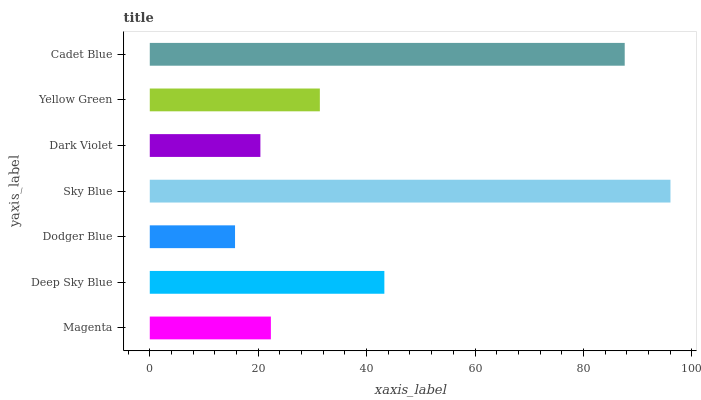Is Dodger Blue the minimum?
Answer yes or no. Yes. Is Sky Blue the maximum?
Answer yes or no. Yes. Is Deep Sky Blue the minimum?
Answer yes or no. No. Is Deep Sky Blue the maximum?
Answer yes or no. No. Is Deep Sky Blue greater than Magenta?
Answer yes or no. Yes. Is Magenta less than Deep Sky Blue?
Answer yes or no. Yes. Is Magenta greater than Deep Sky Blue?
Answer yes or no. No. Is Deep Sky Blue less than Magenta?
Answer yes or no. No. Is Yellow Green the high median?
Answer yes or no. Yes. Is Yellow Green the low median?
Answer yes or no. Yes. Is Sky Blue the high median?
Answer yes or no. No. Is Dodger Blue the low median?
Answer yes or no. No. 